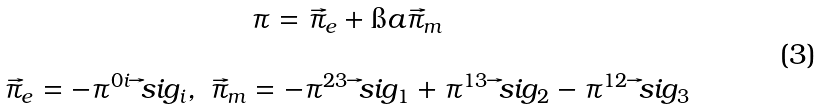Convert formula to latex. <formula><loc_0><loc_0><loc_500><loc_500>\begin{array} { c } \pi = \vec { \pi } _ { e } + \i a \vec { \pi } _ { m } \\ \\ \vec { \pi } _ { e } = - \pi ^ { 0 i } \vec { \ } s i g _ { i } , \ \vec { \pi } _ { m } = - \pi ^ { 2 3 } \vec { \ } s i g _ { 1 } + \pi ^ { 1 3 } \vec { \ } s i g _ { 2 } - \pi ^ { 1 2 } \vec { \ } s i g _ { 3 } \end{array}</formula> 